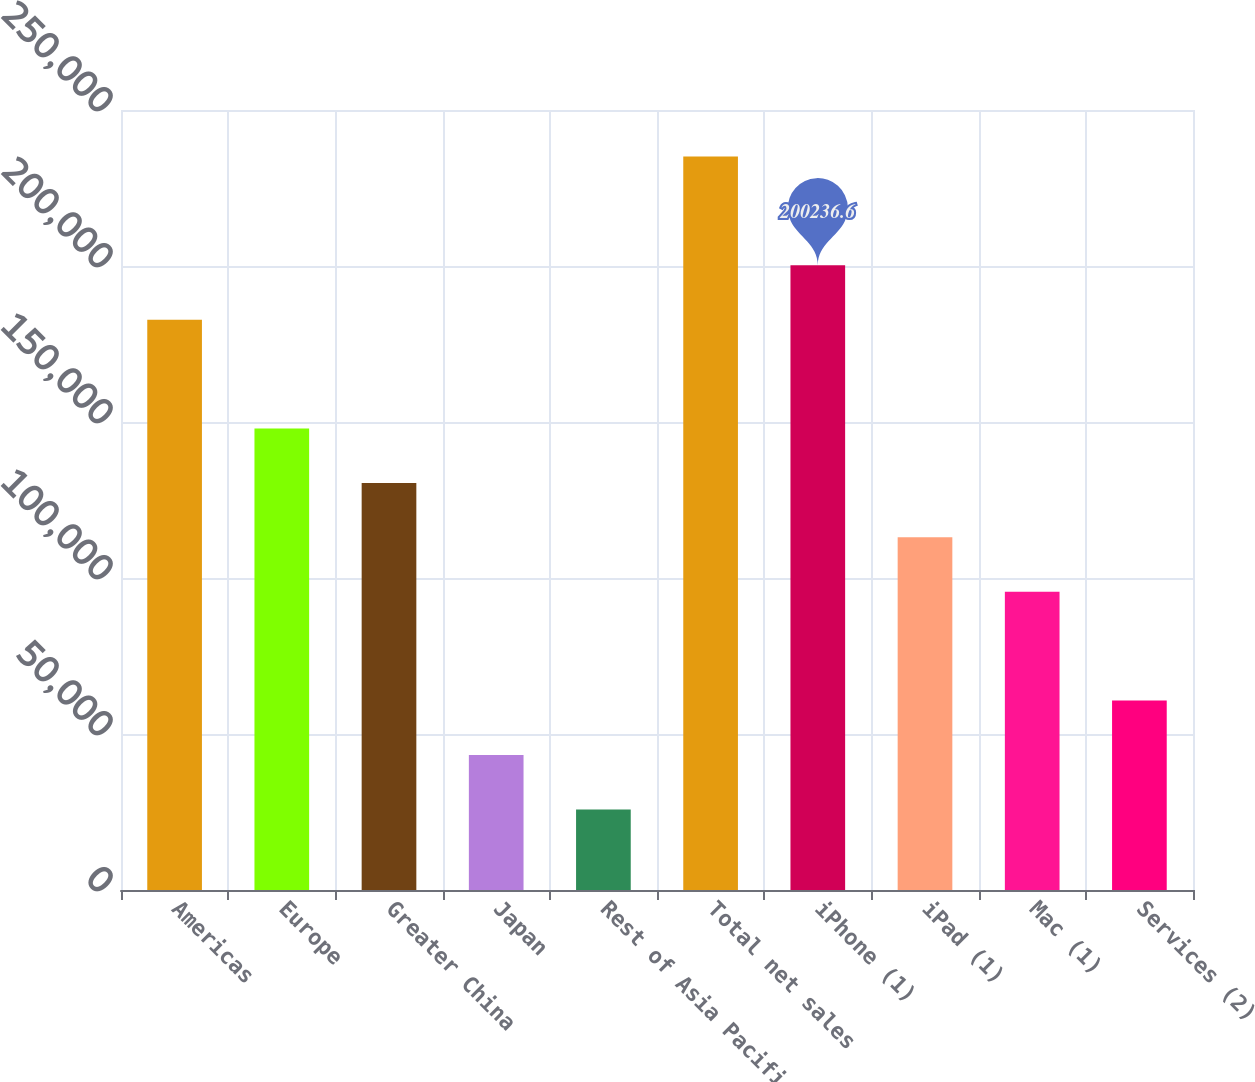Convert chart. <chart><loc_0><loc_0><loc_500><loc_500><bar_chart><fcel>Americas<fcel>Europe<fcel>Greater China<fcel>Japan<fcel>Rest of Asia Pacific<fcel>Total net sales<fcel>iPhone (1)<fcel>iPad (1)<fcel>Mac (1)<fcel>Services (2)<nl><fcel>182795<fcel>147912<fcel>130470<fcel>43262.2<fcel>25820.6<fcel>235120<fcel>200237<fcel>113029<fcel>95587<fcel>60703.8<nl></chart> 